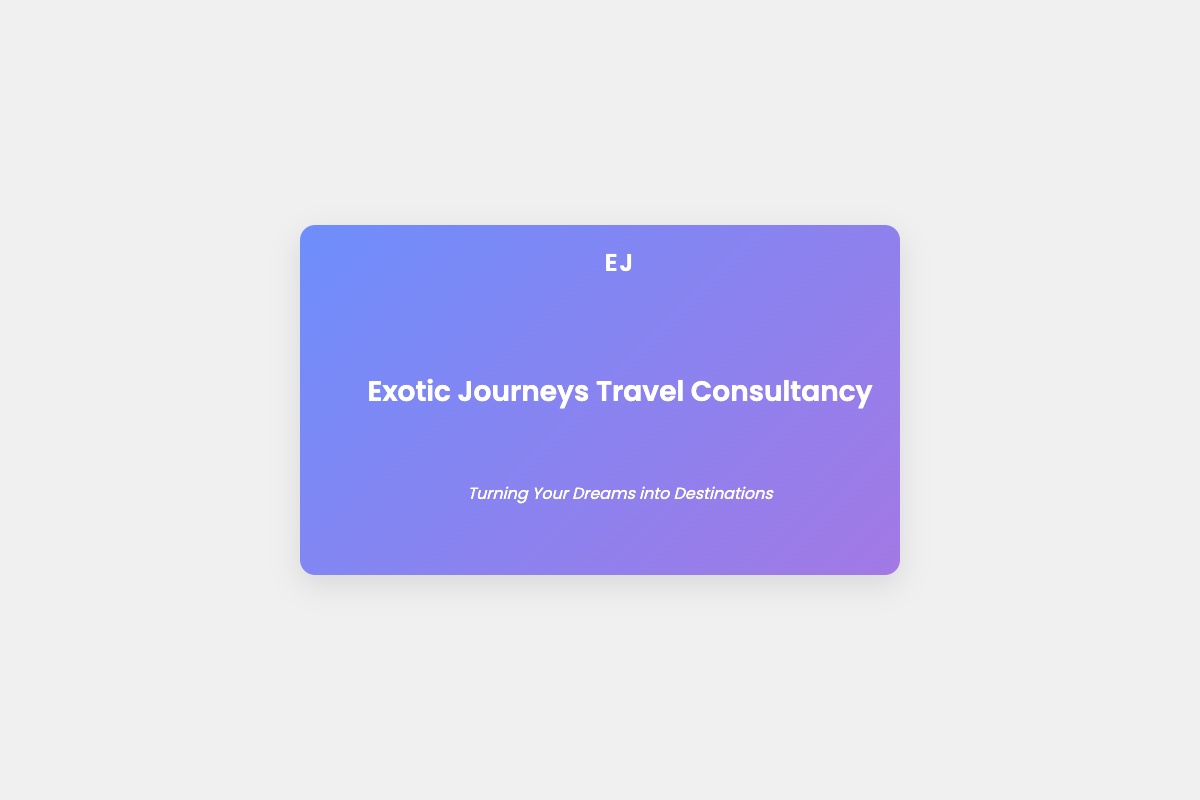What is the company name? The company name is displayed prominently in the document as "Exotic Journeys Travel Consultancy."
Answer: Exotic Journeys Travel Consultancy What is the phone number provided? The phone number is part of the contact information listed on the front of the card.
Answer: +1-800-TRAVELER What services are offered by the travel consultancy? The document lists various services, which include Personalized Itinerary Planning, Luxury Accommodations, Cultural Immersion Experiences, and Adventure Travel.
Answer: Personalized Itinerary Planning, Luxury Accommodations, Cultural Immersion Experiences, Adventure Travel How many countries are mentioned in the document? The back of the card lists four countries that have been visited, which are Japan, Italy, Australia, and Brazil.
Answer: 4 What is the tagline of the company? The tagline appears below the company name and conveys its mission.
Answer: Turning Your Dreams into Destinations Which country is listed last in the countries section? The countries are listed in a specific order, and the last one mentioned is Brazil.
Answer: Brazil What type of document is this? This document is formatted as a business card showcasing travel consultancy services.
Answer: Business card What is included in the footer of the card? The footer features a slogan that emphasizes the company’s aim and identity.
Answer: Transforming Dreams into Reality 